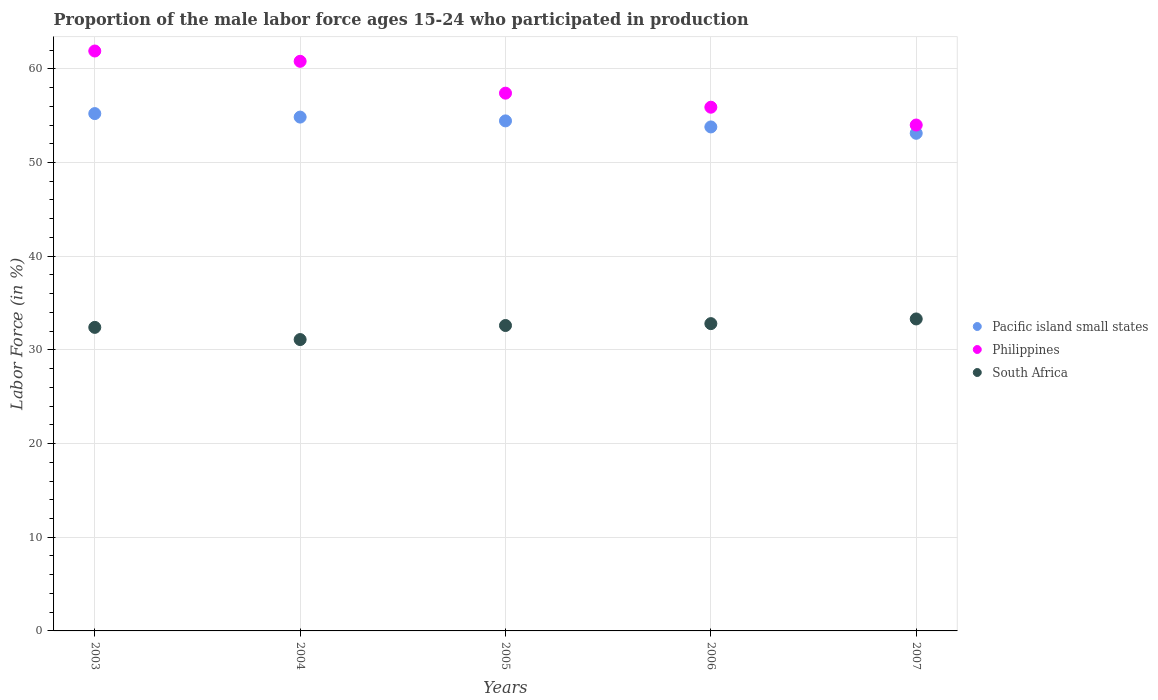Is the number of dotlines equal to the number of legend labels?
Provide a short and direct response. Yes. What is the proportion of the male labor force who participated in production in Philippines in 2003?
Your answer should be very brief. 61.9. Across all years, what is the maximum proportion of the male labor force who participated in production in South Africa?
Offer a terse response. 33.3. Across all years, what is the minimum proportion of the male labor force who participated in production in South Africa?
Provide a short and direct response. 31.1. In which year was the proportion of the male labor force who participated in production in Pacific island small states maximum?
Keep it short and to the point. 2003. In which year was the proportion of the male labor force who participated in production in South Africa minimum?
Your answer should be very brief. 2004. What is the total proportion of the male labor force who participated in production in South Africa in the graph?
Offer a terse response. 162.2. What is the difference between the proportion of the male labor force who participated in production in Pacific island small states in 2003 and that in 2006?
Ensure brevity in your answer.  1.42. What is the difference between the proportion of the male labor force who participated in production in Philippines in 2005 and the proportion of the male labor force who participated in production in Pacific island small states in 2007?
Ensure brevity in your answer.  4.28. What is the average proportion of the male labor force who participated in production in Pacific island small states per year?
Your answer should be compact. 54.28. In the year 2003, what is the difference between the proportion of the male labor force who participated in production in South Africa and proportion of the male labor force who participated in production in Pacific island small states?
Your answer should be very brief. -22.82. What is the ratio of the proportion of the male labor force who participated in production in South Africa in 2005 to that in 2006?
Offer a very short reply. 0.99. What is the difference between the highest and the second highest proportion of the male labor force who participated in production in Pacific island small states?
Your response must be concise. 0.37. What is the difference between the highest and the lowest proportion of the male labor force who participated in production in Pacific island small states?
Provide a succinct answer. 2.1. Is the sum of the proportion of the male labor force who participated in production in South Africa in 2005 and 2006 greater than the maximum proportion of the male labor force who participated in production in Philippines across all years?
Make the answer very short. Yes. Is the proportion of the male labor force who participated in production in South Africa strictly greater than the proportion of the male labor force who participated in production in Pacific island small states over the years?
Ensure brevity in your answer.  No. Is the proportion of the male labor force who participated in production in Philippines strictly less than the proportion of the male labor force who participated in production in Pacific island small states over the years?
Your response must be concise. No. What is the difference between two consecutive major ticks on the Y-axis?
Offer a terse response. 10. How are the legend labels stacked?
Provide a short and direct response. Vertical. What is the title of the graph?
Your response must be concise. Proportion of the male labor force ages 15-24 who participated in production. Does "Norway" appear as one of the legend labels in the graph?
Provide a short and direct response. No. What is the label or title of the Y-axis?
Give a very brief answer. Labor Force (in %). What is the Labor Force (in %) in Pacific island small states in 2003?
Make the answer very short. 55.22. What is the Labor Force (in %) of Philippines in 2003?
Keep it short and to the point. 61.9. What is the Labor Force (in %) in South Africa in 2003?
Your answer should be very brief. 32.4. What is the Labor Force (in %) in Pacific island small states in 2004?
Provide a succinct answer. 54.85. What is the Labor Force (in %) in Philippines in 2004?
Offer a very short reply. 60.8. What is the Labor Force (in %) in South Africa in 2004?
Give a very brief answer. 31.1. What is the Labor Force (in %) of Pacific island small states in 2005?
Give a very brief answer. 54.44. What is the Labor Force (in %) in Philippines in 2005?
Give a very brief answer. 57.4. What is the Labor Force (in %) in South Africa in 2005?
Your response must be concise. 32.6. What is the Labor Force (in %) of Pacific island small states in 2006?
Provide a short and direct response. 53.8. What is the Labor Force (in %) in Philippines in 2006?
Offer a terse response. 55.9. What is the Labor Force (in %) in South Africa in 2006?
Give a very brief answer. 32.8. What is the Labor Force (in %) of Pacific island small states in 2007?
Keep it short and to the point. 53.12. What is the Labor Force (in %) of Philippines in 2007?
Make the answer very short. 54. What is the Labor Force (in %) in South Africa in 2007?
Your response must be concise. 33.3. Across all years, what is the maximum Labor Force (in %) of Pacific island small states?
Your answer should be compact. 55.22. Across all years, what is the maximum Labor Force (in %) of Philippines?
Provide a succinct answer. 61.9. Across all years, what is the maximum Labor Force (in %) in South Africa?
Your answer should be compact. 33.3. Across all years, what is the minimum Labor Force (in %) of Pacific island small states?
Keep it short and to the point. 53.12. Across all years, what is the minimum Labor Force (in %) of South Africa?
Offer a very short reply. 31.1. What is the total Labor Force (in %) of Pacific island small states in the graph?
Make the answer very short. 271.42. What is the total Labor Force (in %) in Philippines in the graph?
Your answer should be very brief. 290. What is the total Labor Force (in %) of South Africa in the graph?
Keep it short and to the point. 162.2. What is the difference between the Labor Force (in %) in Pacific island small states in 2003 and that in 2004?
Your answer should be very brief. 0.37. What is the difference between the Labor Force (in %) in Philippines in 2003 and that in 2004?
Provide a succinct answer. 1.1. What is the difference between the Labor Force (in %) in Pacific island small states in 2003 and that in 2005?
Keep it short and to the point. 0.78. What is the difference between the Labor Force (in %) of Pacific island small states in 2003 and that in 2006?
Your answer should be very brief. 1.42. What is the difference between the Labor Force (in %) in Philippines in 2003 and that in 2006?
Make the answer very short. 6. What is the difference between the Labor Force (in %) of South Africa in 2003 and that in 2006?
Keep it short and to the point. -0.4. What is the difference between the Labor Force (in %) in Pacific island small states in 2003 and that in 2007?
Offer a terse response. 2.1. What is the difference between the Labor Force (in %) of Philippines in 2003 and that in 2007?
Give a very brief answer. 7.9. What is the difference between the Labor Force (in %) of Pacific island small states in 2004 and that in 2005?
Keep it short and to the point. 0.4. What is the difference between the Labor Force (in %) in South Africa in 2004 and that in 2005?
Your answer should be compact. -1.5. What is the difference between the Labor Force (in %) in Pacific island small states in 2004 and that in 2006?
Provide a succinct answer. 1.05. What is the difference between the Labor Force (in %) of Pacific island small states in 2004 and that in 2007?
Make the answer very short. 1.73. What is the difference between the Labor Force (in %) of South Africa in 2004 and that in 2007?
Keep it short and to the point. -2.2. What is the difference between the Labor Force (in %) of Pacific island small states in 2005 and that in 2006?
Make the answer very short. 0.65. What is the difference between the Labor Force (in %) in Pacific island small states in 2005 and that in 2007?
Offer a very short reply. 1.32. What is the difference between the Labor Force (in %) of Philippines in 2005 and that in 2007?
Provide a succinct answer. 3.4. What is the difference between the Labor Force (in %) of Pacific island small states in 2006 and that in 2007?
Offer a very short reply. 0.68. What is the difference between the Labor Force (in %) in Philippines in 2006 and that in 2007?
Give a very brief answer. 1.9. What is the difference between the Labor Force (in %) of Pacific island small states in 2003 and the Labor Force (in %) of Philippines in 2004?
Ensure brevity in your answer.  -5.58. What is the difference between the Labor Force (in %) of Pacific island small states in 2003 and the Labor Force (in %) of South Africa in 2004?
Your answer should be very brief. 24.12. What is the difference between the Labor Force (in %) of Philippines in 2003 and the Labor Force (in %) of South Africa in 2004?
Your response must be concise. 30.8. What is the difference between the Labor Force (in %) in Pacific island small states in 2003 and the Labor Force (in %) in Philippines in 2005?
Make the answer very short. -2.18. What is the difference between the Labor Force (in %) in Pacific island small states in 2003 and the Labor Force (in %) in South Africa in 2005?
Your answer should be compact. 22.62. What is the difference between the Labor Force (in %) in Philippines in 2003 and the Labor Force (in %) in South Africa in 2005?
Offer a very short reply. 29.3. What is the difference between the Labor Force (in %) in Pacific island small states in 2003 and the Labor Force (in %) in Philippines in 2006?
Your response must be concise. -0.68. What is the difference between the Labor Force (in %) in Pacific island small states in 2003 and the Labor Force (in %) in South Africa in 2006?
Your response must be concise. 22.42. What is the difference between the Labor Force (in %) in Philippines in 2003 and the Labor Force (in %) in South Africa in 2006?
Offer a very short reply. 29.1. What is the difference between the Labor Force (in %) of Pacific island small states in 2003 and the Labor Force (in %) of Philippines in 2007?
Offer a terse response. 1.22. What is the difference between the Labor Force (in %) in Pacific island small states in 2003 and the Labor Force (in %) in South Africa in 2007?
Make the answer very short. 21.92. What is the difference between the Labor Force (in %) of Philippines in 2003 and the Labor Force (in %) of South Africa in 2007?
Keep it short and to the point. 28.6. What is the difference between the Labor Force (in %) of Pacific island small states in 2004 and the Labor Force (in %) of Philippines in 2005?
Offer a very short reply. -2.55. What is the difference between the Labor Force (in %) of Pacific island small states in 2004 and the Labor Force (in %) of South Africa in 2005?
Your answer should be compact. 22.25. What is the difference between the Labor Force (in %) of Philippines in 2004 and the Labor Force (in %) of South Africa in 2005?
Provide a succinct answer. 28.2. What is the difference between the Labor Force (in %) of Pacific island small states in 2004 and the Labor Force (in %) of Philippines in 2006?
Keep it short and to the point. -1.05. What is the difference between the Labor Force (in %) of Pacific island small states in 2004 and the Labor Force (in %) of South Africa in 2006?
Your answer should be compact. 22.05. What is the difference between the Labor Force (in %) of Philippines in 2004 and the Labor Force (in %) of South Africa in 2006?
Offer a very short reply. 28. What is the difference between the Labor Force (in %) of Pacific island small states in 2004 and the Labor Force (in %) of Philippines in 2007?
Your response must be concise. 0.85. What is the difference between the Labor Force (in %) in Pacific island small states in 2004 and the Labor Force (in %) in South Africa in 2007?
Ensure brevity in your answer.  21.55. What is the difference between the Labor Force (in %) of Pacific island small states in 2005 and the Labor Force (in %) of Philippines in 2006?
Your response must be concise. -1.46. What is the difference between the Labor Force (in %) in Pacific island small states in 2005 and the Labor Force (in %) in South Africa in 2006?
Your response must be concise. 21.64. What is the difference between the Labor Force (in %) in Philippines in 2005 and the Labor Force (in %) in South Africa in 2006?
Ensure brevity in your answer.  24.6. What is the difference between the Labor Force (in %) of Pacific island small states in 2005 and the Labor Force (in %) of Philippines in 2007?
Offer a very short reply. 0.44. What is the difference between the Labor Force (in %) of Pacific island small states in 2005 and the Labor Force (in %) of South Africa in 2007?
Offer a terse response. 21.14. What is the difference between the Labor Force (in %) in Philippines in 2005 and the Labor Force (in %) in South Africa in 2007?
Offer a very short reply. 24.1. What is the difference between the Labor Force (in %) in Pacific island small states in 2006 and the Labor Force (in %) in Philippines in 2007?
Your answer should be very brief. -0.2. What is the difference between the Labor Force (in %) in Pacific island small states in 2006 and the Labor Force (in %) in South Africa in 2007?
Provide a short and direct response. 20.5. What is the difference between the Labor Force (in %) of Philippines in 2006 and the Labor Force (in %) of South Africa in 2007?
Provide a succinct answer. 22.6. What is the average Labor Force (in %) of Pacific island small states per year?
Ensure brevity in your answer.  54.28. What is the average Labor Force (in %) of Philippines per year?
Your answer should be compact. 58. What is the average Labor Force (in %) of South Africa per year?
Your answer should be very brief. 32.44. In the year 2003, what is the difference between the Labor Force (in %) in Pacific island small states and Labor Force (in %) in Philippines?
Provide a succinct answer. -6.68. In the year 2003, what is the difference between the Labor Force (in %) in Pacific island small states and Labor Force (in %) in South Africa?
Provide a short and direct response. 22.82. In the year 2003, what is the difference between the Labor Force (in %) in Philippines and Labor Force (in %) in South Africa?
Offer a very short reply. 29.5. In the year 2004, what is the difference between the Labor Force (in %) of Pacific island small states and Labor Force (in %) of Philippines?
Make the answer very short. -5.95. In the year 2004, what is the difference between the Labor Force (in %) of Pacific island small states and Labor Force (in %) of South Africa?
Provide a short and direct response. 23.75. In the year 2004, what is the difference between the Labor Force (in %) of Philippines and Labor Force (in %) of South Africa?
Your answer should be very brief. 29.7. In the year 2005, what is the difference between the Labor Force (in %) in Pacific island small states and Labor Force (in %) in Philippines?
Provide a short and direct response. -2.96. In the year 2005, what is the difference between the Labor Force (in %) of Pacific island small states and Labor Force (in %) of South Africa?
Your answer should be very brief. 21.84. In the year 2005, what is the difference between the Labor Force (in %) of Philippines and Labor Force (in %) of South Africa?
Provide a short and direct response. 24.8. In the year 2006, what is the difference between the Labor Force (in %) of Pacific island small states and Labor Force (in %) of Philippines?
Keep it short and to the point. -2.1. In the year 2006, what is the difference between the Labor Force (in %) in Pacific island small states and Labor Force (in %) in South Africa?
Your response must be concise. 21. In the year 2006, what is the difference between the Labor Force (in %) of Philippines and Labor Force (in %) of South Africa?
Ensure brevity in your answer.  23.1. In the year 2007, what is the difference between the Labor Force (in %) in Pacific island small states and Labor Force (in %) in Philippines?
Make the answer very short. -0.88. In the year 2007, what is the difference between the Labor Force (in %) in Pacific island small states and Labor Force (in %) in South Africa?
Offer a terse response. 19.82. In the year 2007, what is the difference between the Labor Force (in %) in Philippines and Labor Force (in %) in South Africa?
Keep it short and to the point. 20.7. What is the ratio of the Labor Force (in %) of Pacific island small states in 2003 to that in 2004?
Your answer should be compact. 1.01. What is the ratio of the Labor Force (in %) in Philippines in 2003 to that in 2004?
Your response must be concise. 1.02. What is the ratio of the Labor Force (in %) in South Africa in 2003 to that in 2004?
Keep it short and to the point. 1.04. What is the ratio of the Labor Force (in %) of Pacific island small states in 2003 to that in 2005?
Offer a very short reply. 1.01. What is the ratio of the Labor Force (in %) of Philippines in 2003 to that in 2005?
Keep it short and to the point. 1.08. What is the ratio of the Labor Force (in %) in Pacific island small states in 2003 to that in 2006?
Ensure brevity in your answer.  1.03. What is the ratio of the Labor Force (in %) of Philippines in 2003 to that in 2006?
Provide a short and direct response. 1.11. What is the ratio of the Labor Force (in %) of South Africa in 2003 to that in 2006?
Provide a succinct answer. 0.99. What is the ratio of the Labor Force (in %) in Pacific island small states in 2003 to that in 2007?
Give a very brief answer. 1.04. What is the ratio of the Labor Force (in %) in Philippines in 2003 to that in 2007?
Your answer should be very brief. 1.15. What is the ratio of the Labor Force (in %) in Pacific island small states in 2004 to that in 2005?
Give a very brief answer. 1.01. What is the ratio of the Labor Force (in %) in Philippines in 2004 to that in 2005?
Offer a very short reply. 1.06. What is the ratio of the Labor Force (in %) in South Africa in 2004 to that in 2005?
Your answer should be very brief. 0.95. What is the ratio of the Labor Force (in %) of Pacific island small states in 2004 to that in 2006?
Provide a short and direct response. 1.02. What is the ratio of the Labor Force (in %) of Philippines in 2004 to that in 2006?
Provide a short and direct response. 1.09. What is the ratio of the Labor Force (in %) in South Africa in 2004 to that in 2006?
Keep it short and to the point. 0.95. What is the ratio of the Labor Force (in %) of Pacific island small states in 2004 to that in 2007?
Your answer should be compact. 1.03. What is the ratio of the Labor Force (in %) in Philippines in 2004 to that in 2007?
Your answer should be compact. 1.13. What is the ratio of the Labor Force (in %) in South Africa in 2004 to that in 2007?
Offer a very short reply. 0.93. What is the ratio of the Labor Force (in %) of Pacific island small states in 2005 to that in 2006?
Give a very brief answer. 1.01. What is the ratio of the Labor Force (in %) of Philippines in 2005 to that in 2006?
Ensure brevity in your answer.  1.03. What is the ratio of the Labor Force (in %) in South Africa in 2005 to that in 2006?
Your response must be concise. 0.99. What is the ratio of the Labor Force (in %) of Pacific island small states in 2005 to that in 2007?
Provide a succinct answer. 1.02. What is the ratio of the Labor Force (in %) of Philippines in 2005 to that in 2007?
Your response must be concise. 1.06. What is the ratio of the Labor Force (in %) of Pacific island small states in 2006 to that in 2007?
Offer a very short reply. 1.01. What is the ratio of the Labor Force (in %) of Philippines in 2006 to that in 2007?
Offer a terse response. 1.04. What is the difference between the highest and the second highest Labor Force (in %) in Pacific island small states?
Your response must be concise. 0.37. What is the difference between the highest and the second highest Labor Force (in %) in Philippines?
Keep it short and to the point. 1.1. What is the difference between the highest and the lowest Labor Force (in %) in Pacific island small states?
Provide a succinct answer. 2.1. What is the difference between the highest and the lowest Labor Force (in %) of Philippines?
Provide a short and direct response. 7.9. What is the difference between the highest and the lowest Labor Force (in %) in South Africa?
Provide a succinct answer. 2.2. 